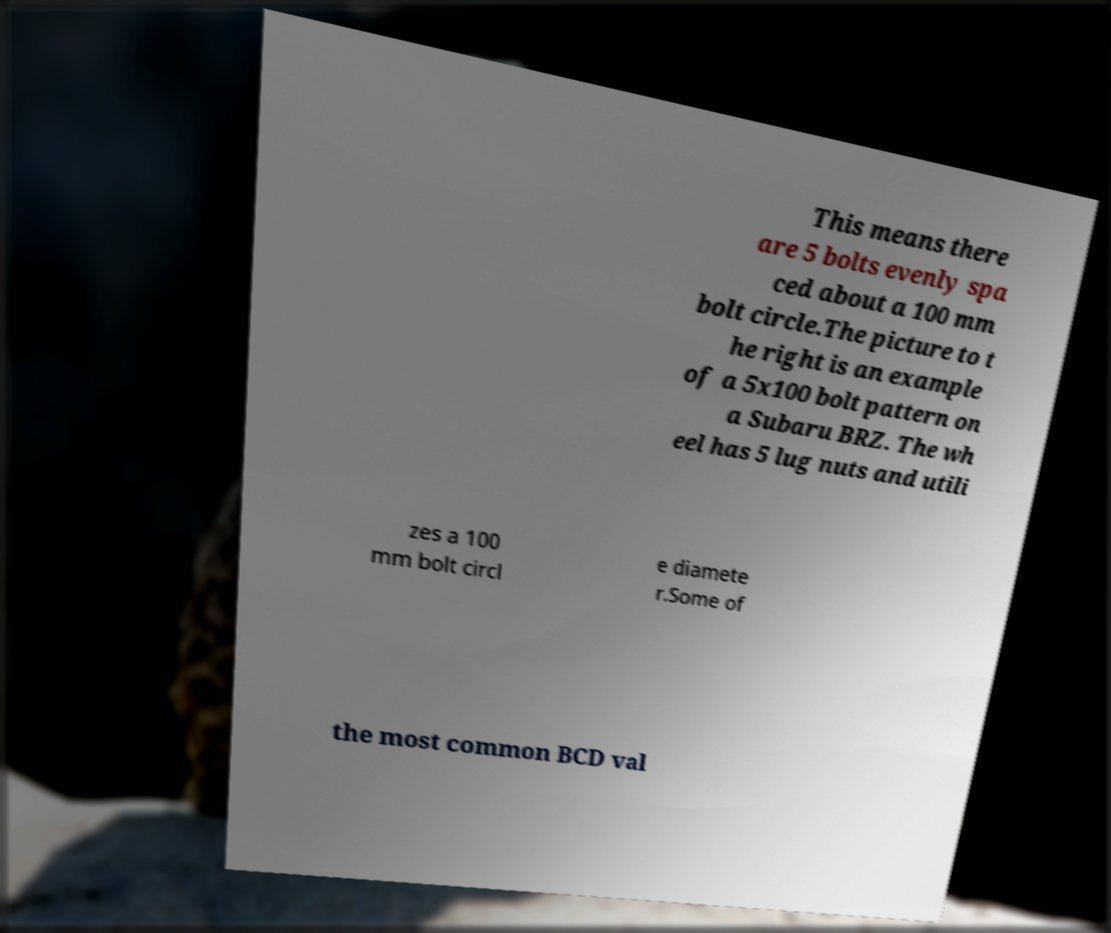Please identify and transcribe the text found in this image. This means there are 5 bolts evenly spa ced about a 100 mm bolt circle.The picture to t he right is an example of a 5x100 bolt pattern on a Subaru BRZ. The wh eel has 5 lug nuts and utili zes a 100 mm bolt circl e diamete r.Some of the most common BCD val 